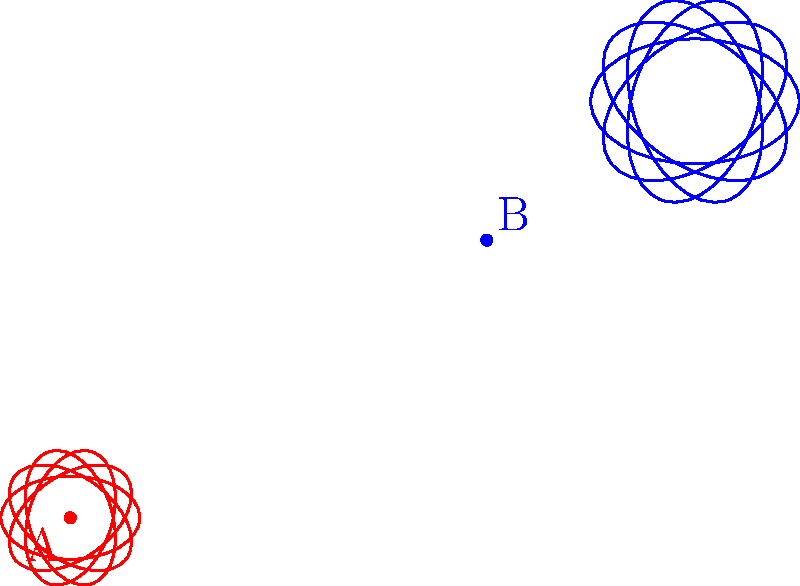A simplified diagram of a Hypericum flower is shown in red, centered at point A. A scaled and translated version of the same flower, representing a different Hypericum species, is shown in blue, centered at point B. If the red flower has a diameter of 2 cm, what is the diameter of the blue flower, and what are the coordinates of its center relative to the original flower's center? To solve this problem, we need to analyze the transformation applied to the original flower:

1. Scaling:
   The blue flower appears larger than the red one. To determine the scale factor, we need to compare their sizes. The blue flower is 1.5 times larger than the red one.

2. Translation:
   The center of the blue flower (point B) has been moved relative to the center of the red flower (point A). We can see that it has been shifted 3 units to the right and 2 units up.

3. Calculating the new diameter:
   Original diameter = 2 cm
   Scale factor = 1.5
   New diameter = Original diameter × Scale factor
   New diameter = 2 cm × 1.5 = 3 cm

4. Determining the coordinates of the new center:
   The translation is (3, 2) units from the original center.

Therefore, the blue flower has a diameter of 3 cm, and its center is located at coordinates (3, 2) relative to the center of the original red flower.
Answer: 3 cm diameter, center at (3, 2) 